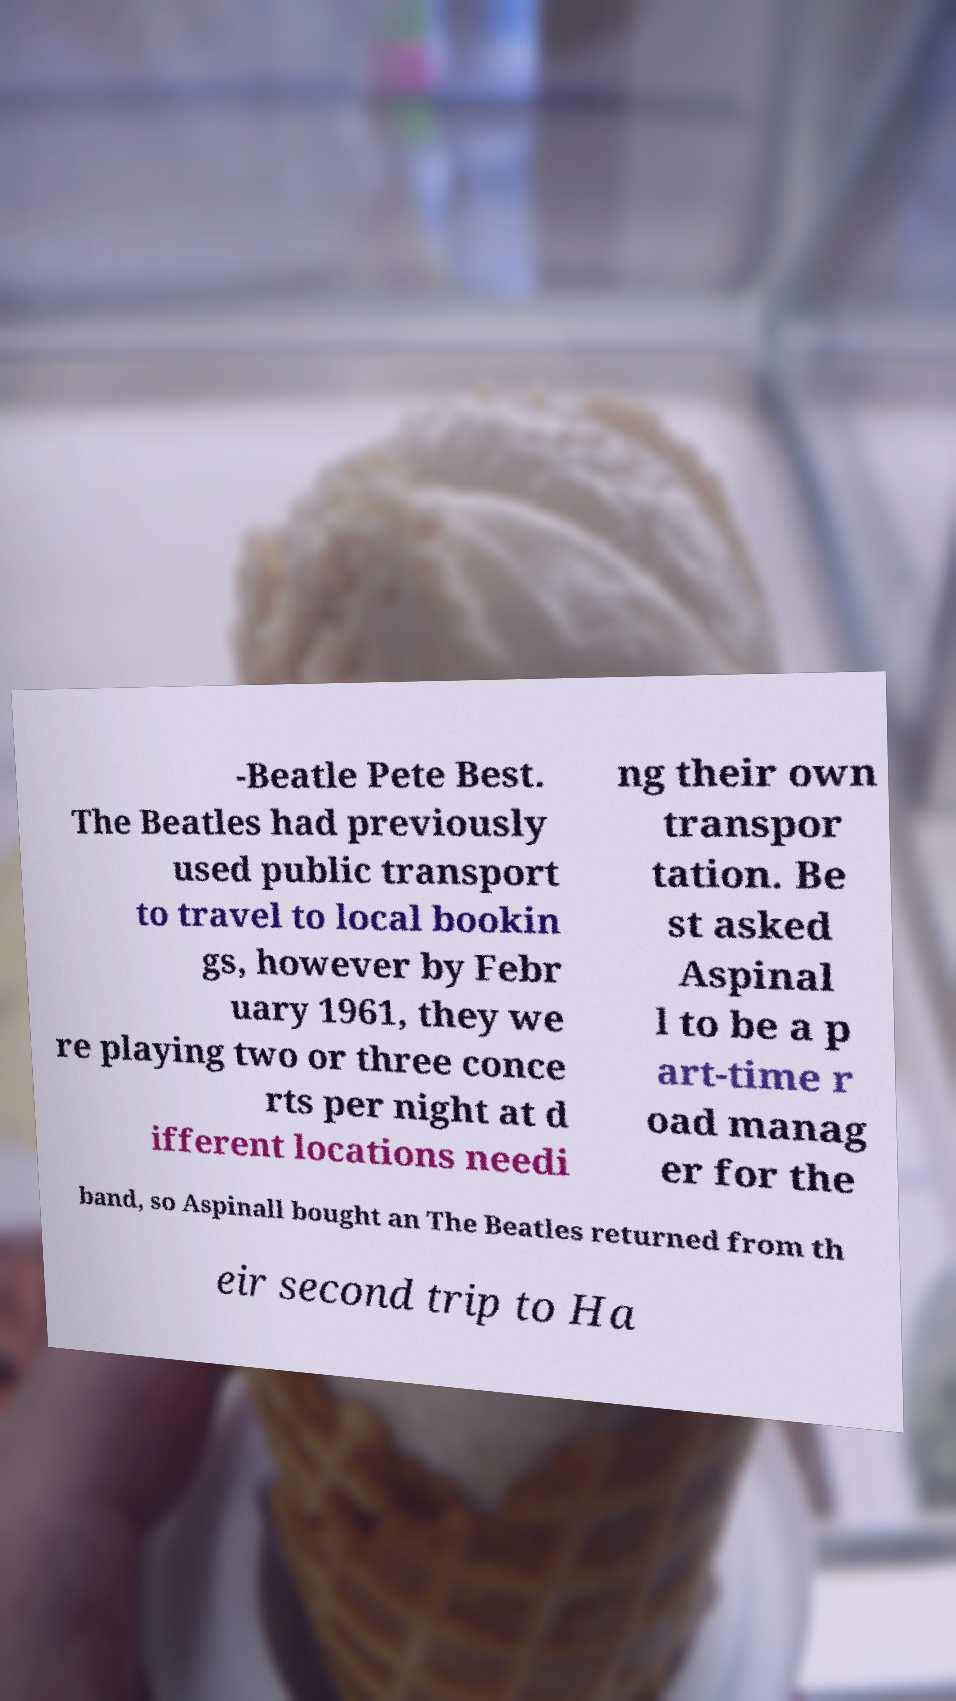Can you accurately transcribe the text from the provided image for me? -Beatle Pete Best. The Beatles had previously used public transport to travel to local bookin gs, however by Febr uary 1961, they we re playing two or three conce rts per night at d ifferent locations needi ng their own transpor tation. Be st asked Aspinal l to be a p art-time r oad manag er for the band, so Aspinall bought an The Beatles returned from th eir second trip to Ha 